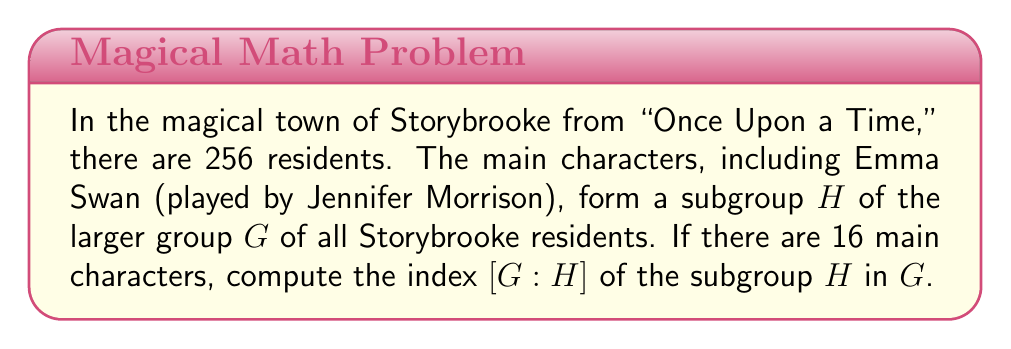Could you help me with this problem? To solve this problem, we need to understand the concept of index in group theory and apply it to the given scenario.

1) The index of a subgroup $H$ in a group $G$, denoted as $[G:H]$, is defined as the number of distinct left cosets of $H$ in $G$.

2) For finite groups, the index is equal to the quotient of the orders of the groups:

   $$[G:H] = \frac{|G|}{|H|}$$

   Where $|G|$ is the order (number of elements) of group $G$, and $|H|$ is the order of subgroup $H$.

3) In this case:
   - $|G|$ = 256 (total number of Storybrooke residents)
   - $|H|$ = 16 (number of main characters)

4) Applying the formula:

   $$[G:H] = \frac{|G|}{|H|} = \frac{256}{16}$$

5) Simplify:
   
   $$\frac{256}{16} = 16$$

Therefore, the index of the subgroup of main characters in the group of all Storybrooke residents is 16.
Answer: $[G:H] = 16$ 